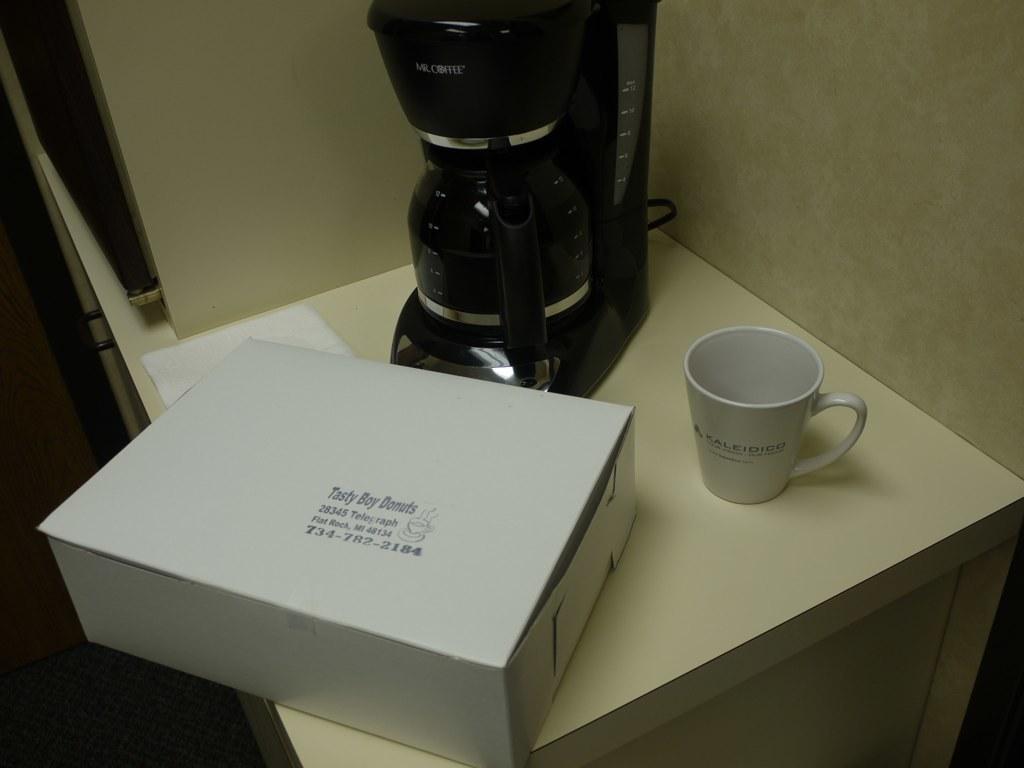What brand of donuts is this?
Provide a short and direct response. Tasty boy. What state are the donuts from?
Make the answer very short. Michigan. 